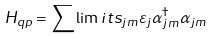Convert formula to latex. <formula><loc_0><loc_0><loc_500><loc_500>H _ { q p } = \sum \lim i t s _ { j m } \varepsilon _ { j } \alpha _ { j m } ^ { \dagger } \alpha _ { j m }</formula> 